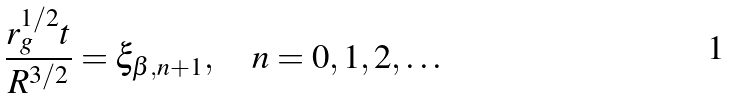Convert formula to latex. <formula><loc_0><loc_0><loc_500><loc_500>\frac { r _ { g } ^ { 1 / 2 } t } { R ^ { 3 / 2 } } = \xi _ { \beta , n + 1 } , \quad n = 0 , 1 , 2 , \dots</formula> 